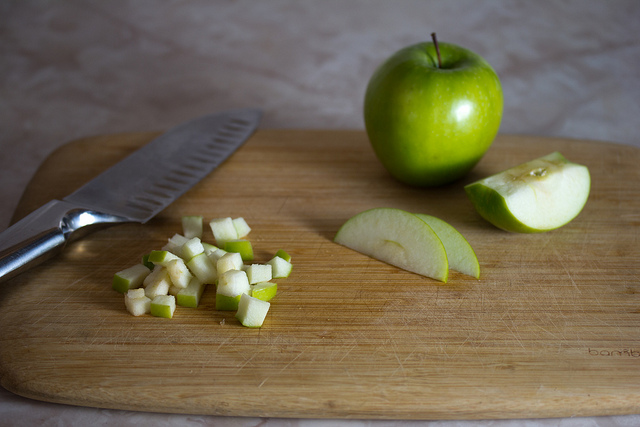What are the potential health benefits of including apples in your diet as seen in various forms on the cutting board? Apples are incredibly beneficial for health; they're rich in dietary fiber, which aids in digestion, and contain vitamin C that supports the immune system. The varied forms of apples on the cutting board suggest multipurpose uses, from eating raw for maximum nutrients to cooking, which can enhance their natural sweetness without adding calories. 